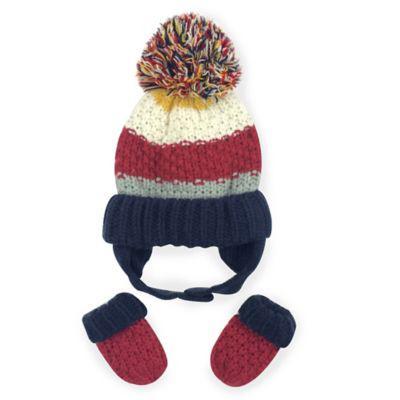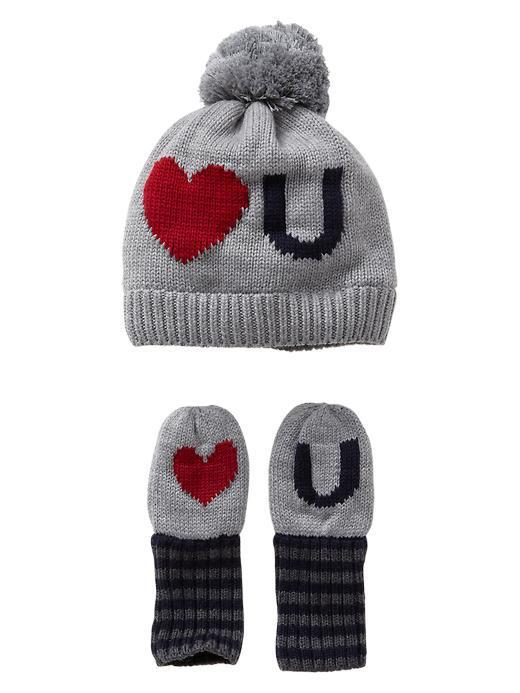The first image is the image on the left, the second image is the image on the right. For the images displayed, is the sentence "Exactly two knit hats are multicolor with a ribbed bottom and a pompon on top, with a set of matching mittens shown below the hat." factually correct? Answer yes or no. Yes. The first image is the image on the left, the second image is the image on the right. Analyze the images presented: Is the assertion "One hat has an animal face on it." valid? Answer yes or no. No. 